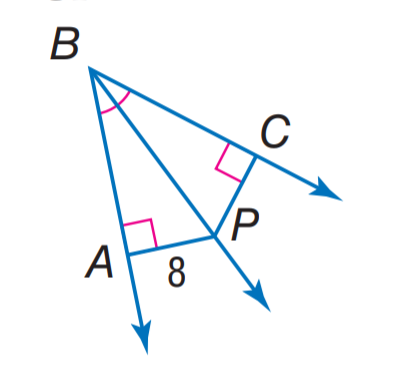Answer the mathemtical geometry problem and directly provide the correct option letter.
Question: Find C P.
Choices: A: 4 B: 8 C: 10 D: 12 B 